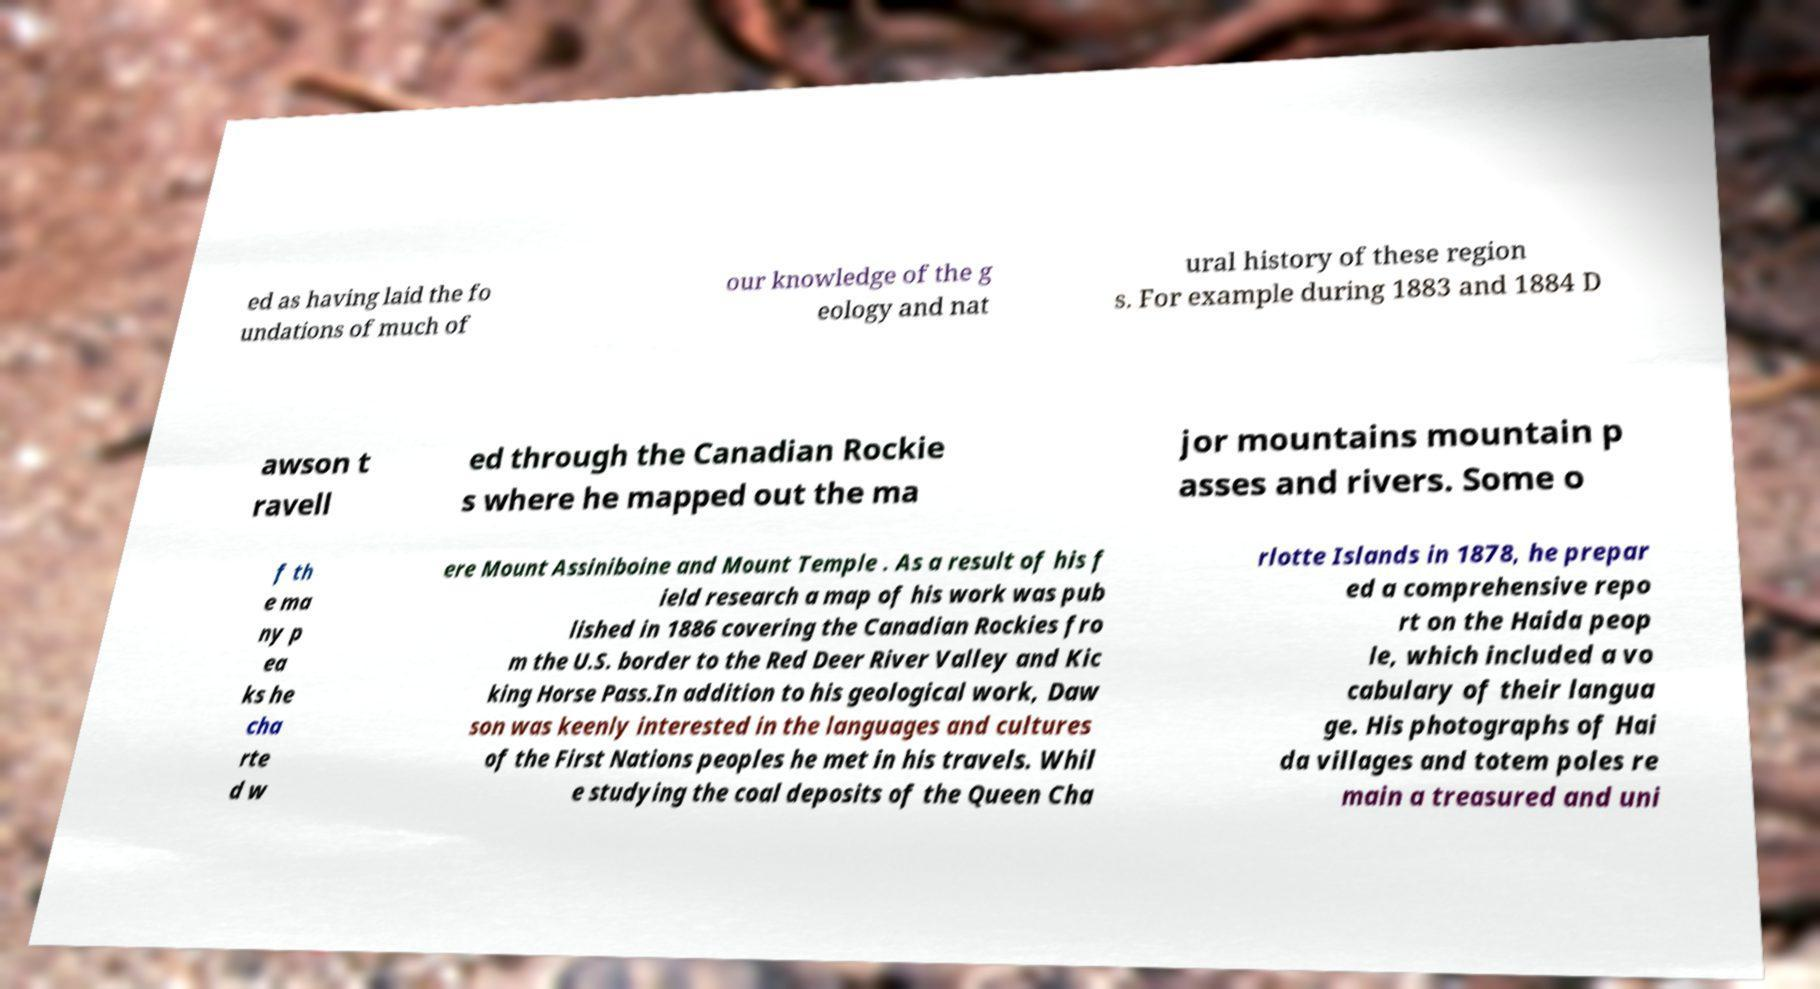For documentation purposes, I need the text within this image transcribed. Could you provide that? ed as having laid the fo undations of much of our knowledge of the g eology and nat ural history of these region s. For example during 1883 and 1884 D awson t ravell ed through the Canadian Rockie s where he mapped out the ma jor mountains mountain p asses and rivers. Some o f th e ma ny p ea ks he cha rte d w ere Mount Assiniboine and Mount Temple . As a result of his f ield research a map of his work was pub lished in 1886 covering the Canadian Rockies fro m the U.S. border to the Red Deer River Valley and Kic king Horse Pass.In addition to his geological work, Daw son was keenly interested in the languages and cultures of the First Nations peoples he met in his travels. Whil e studying the coal deposits of the Queen Cha rlotte Islands in 1878, he prepar ed a comprehensive repo rt on the Haida peop le, which included a vo cabulary of their langua ge. His photographs of Hai da villages and totem poles re main a treasured and uni 